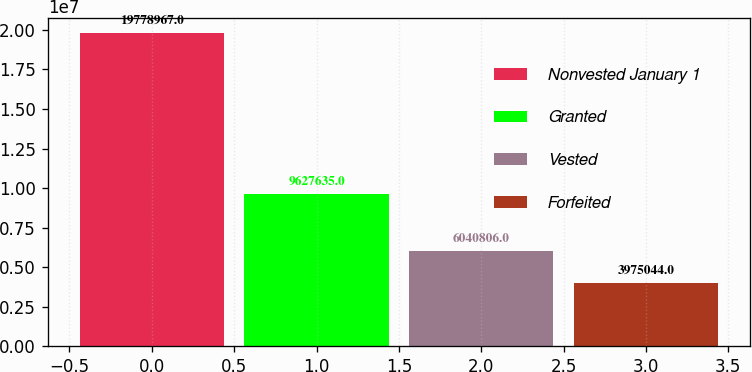Convert chart to OTSL. <chart><loc_0><loc_0><loc_500><loc_500><bar_chart><fcel>Nonvested January 1<fcel>Granted<fcel>Vested<fcel>Forfeited<nl><fcel>1.9779e+07<fcel>9.62764e+06<fcel>6.04081e+06<fcel>3.97504e+06<nl></chart> 